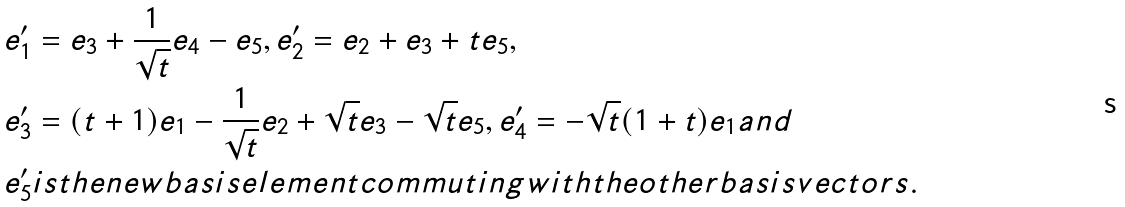Convert formula to latex. <formula><loc_0><loc_0><loc_500><loc_500>& e ^ { \prime } _ { 1 } = e _ { 3 } + \frac { 1 } { \sqrt { t } } e _ { 4 } - e _ { 5 } , e ^ { \prime } _ { 2 } = e _ { 2 } + e _ { 3 } + t e _ { 5 } , \\ & e ^ { \prime } _ { 3 } = ( t + 1 ) e _ { 1 } - \frac { 1 } { \sqrt { t } } e _ { 2 } + \sqrt { t } e _ { 3 } - \sqrt { t } e _ { 5 } , e ^ { \prime } _ { 4 } = - \sqrt { t } ( 1 + t ) e _ { 1 } a n d \\ & e _ { 5 } ^ { \prime } i s t h e n e w b a s i s e l e m e n t c o m m u t i n g w i t h t h e o t h e r b a s i s v e c t o r s .</formula> 